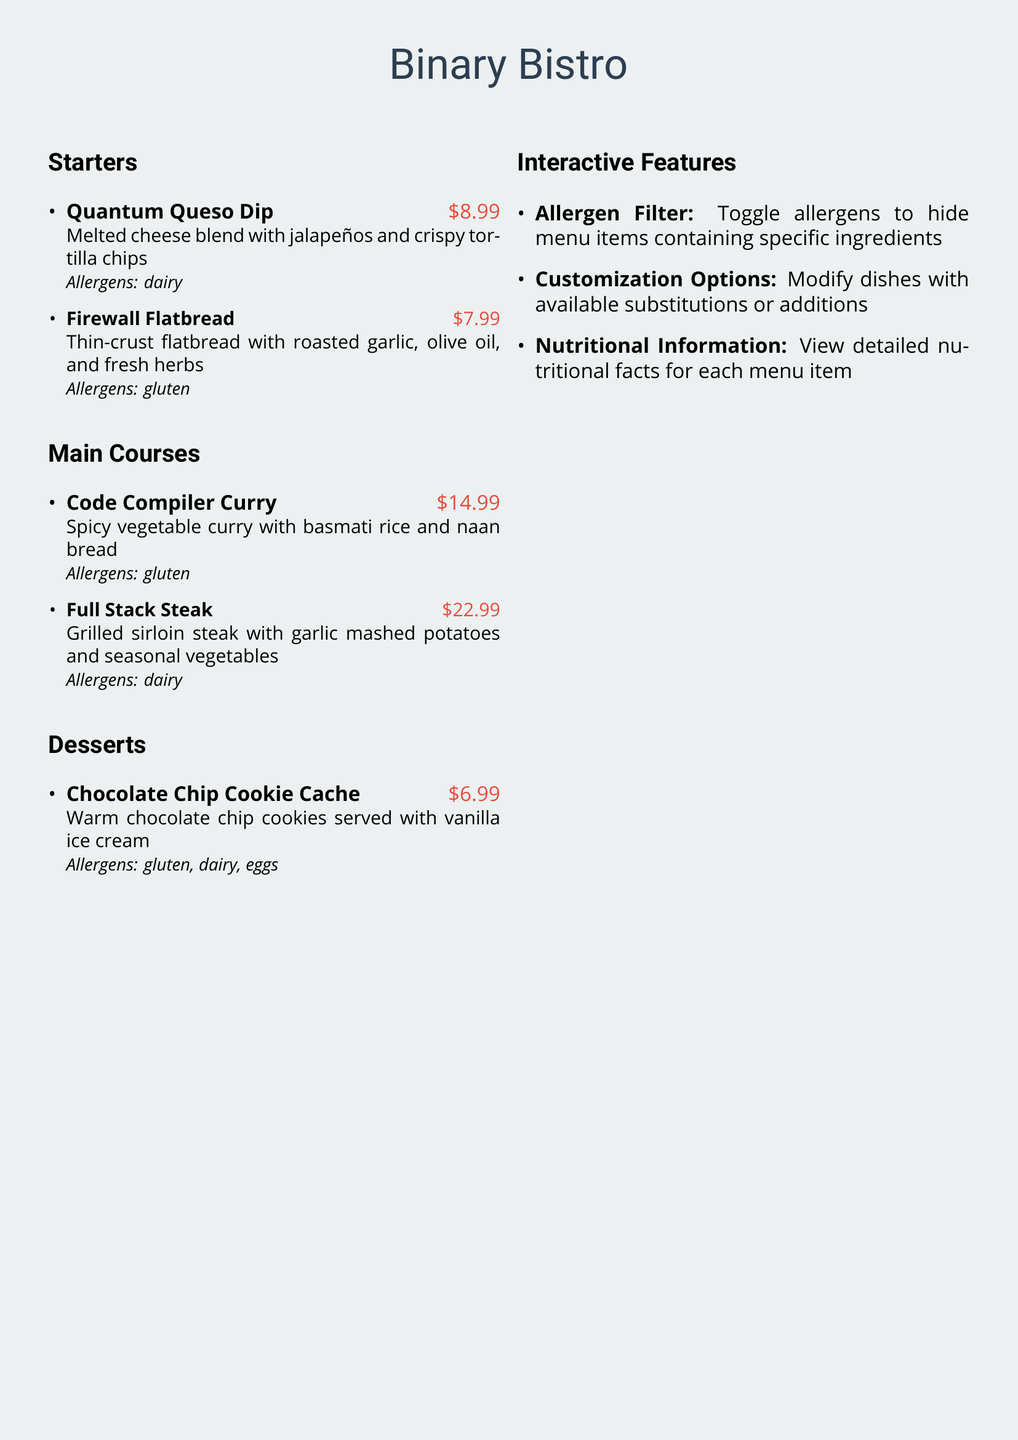What is the price of the Quantum Queso Dip? The price of the Quantum Queso Dip is stated in the menu and is $8.99.
Answer: $8.99 How many main course options are listed? The main courses section contains a count of the dishes listed, which are two items: Code Compiler Curry and Full Stack Steak.
Answer: 2 What allergen is present in the Chocolate Chip Cookie Cache? The allergens included for the Chocolate Chip Cookie Cache are mentioned in the menu and include gluten, dairy, and eggs.
Answer: gluten, dairy, eggs Which dish is the most expensive? The menu provides pricing for all items, identifying the Full Stack Steak as the highest at $22.99.
Answer: Full Stack Steak What feature allows hiding menu items based on allergens? The document describes a specific feature that enables viewing options without specific allergens, identified as the allergen filter.
Answer: Allergen Filter What is the serving size for the Code Compiler Curry? The menu includes a description of the servings and sides accompanied with Code Compiler Curry, which states it comes with basmati rice and naan bread.
Answer: basmati rice and naan bread What kind of ice cream is served with the Chocolate Chip Cookie Cache? The menu lists the dessert specifically mentioning vanilla ice cream served alongside cookies.
Answer: vanilla ice cream What does the customization options feature offer? The customization options feature enables adjustments to the dishes based on available substitutions or additions, as mentioned in the interactive features section.
Answer: Modify dishes 